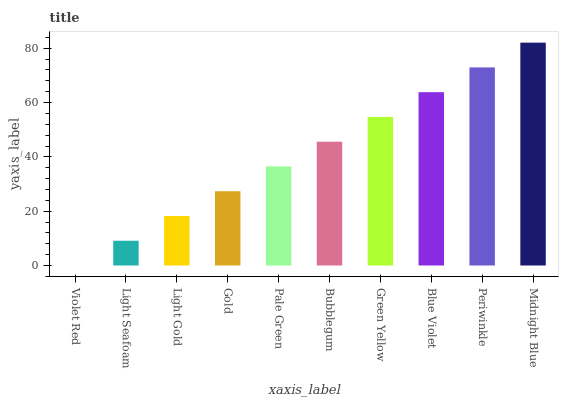Is Violet Red the minimum?
Answer yes or no. Yes. Is Midnight Blue the maximum?
Answer yes or no. Yes. Is Light Seafoam the minimum?
Answer yes or no. No. Is Light Seafoam the maximum?
Answer yes or no. No. Is Light Seafoam greater than Violet Red?
Answer yes or no. Yes. Is Violet Red less than Light Seafoam?
Answer yes or no. Yes. Is Violet Red greater than Light Seafoam?
Answer yes or no. No. Is Light Seafoam less than Violet Red?
Answer yes or no. No. Is Bubblegum the high median?
Answer yes or no. Yes. Is Pale Green the low median?
Answer yes or no. Yes. Is Light Gold the high median?
Answer yes or no. No. Is Light Gold the low median?
Answer yes or no. No. 